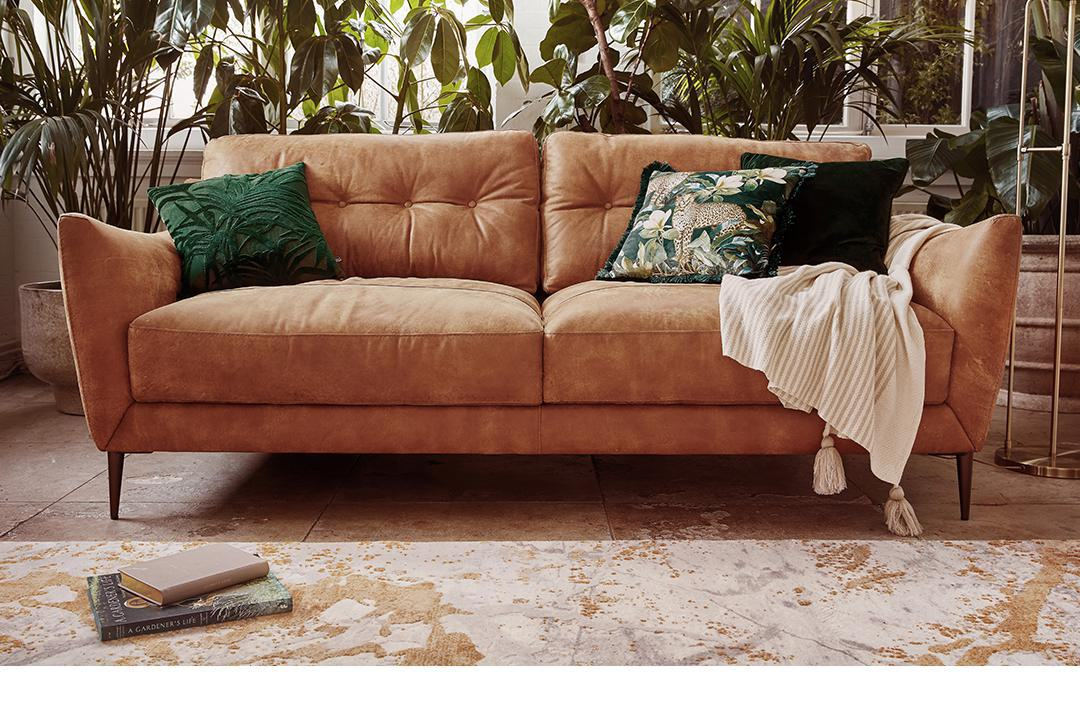Are there any signs of the room being used recently? Yes, there are subtle signs indicating recent use, such as the casually draped throw blanket on the sofa, and two books placed on the floor beside it, conveying a lived-in yet tidy atmosphere. 